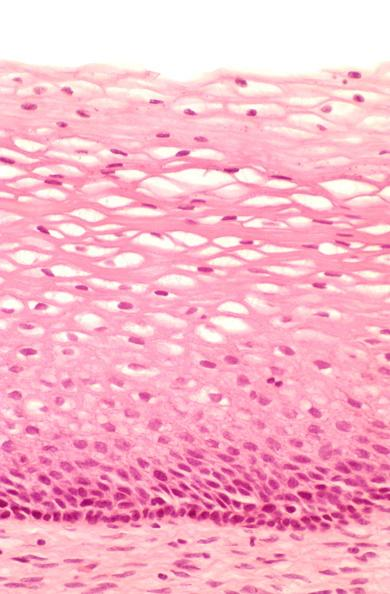where is this from?
Answer the question using a single word or phrase. Female reproductive system 